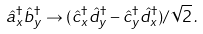Convert formula to latex. <formula><loc_0><loc_0><loc_500><loc_500>\hat { a } _ { x } ^ { \dagger } \hat { b } _ { y } ^ { \dagger } \rightarrow ( \hat { c } _ { x } ^ { \dagger } \hat { d } _ { y } ^ { \dagger } - \hat { c } _ { y } ^ { \dagger } \hat { d } _ { x } ^ { \dagger } ) / \sqrt { 2 } \, .</formula> 